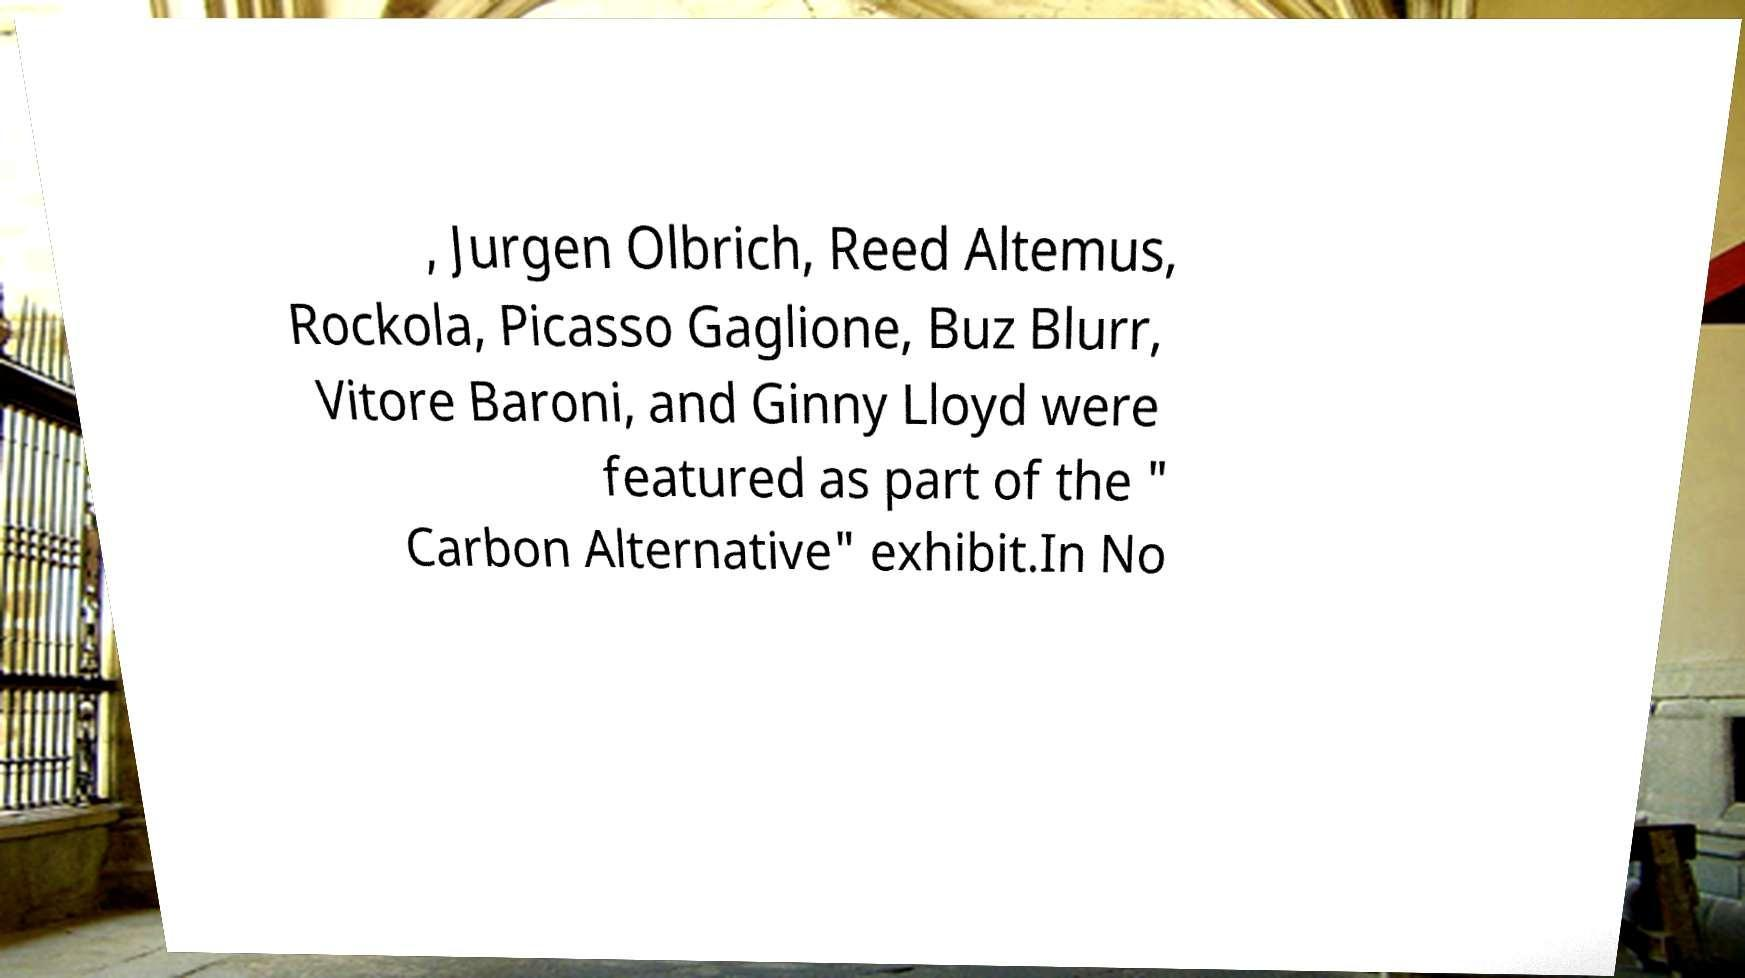There's text embedded in this image that I need extracted. Can you transcribe it verbatim? , Jurgen Olbrich, Reed Altemus, Rockola, Picasso Gaglione, Buz Blurr, Vitore Baroni, and Ginny Lloyd were featured as part of the " Carbon Alternative" exhibit.In No 